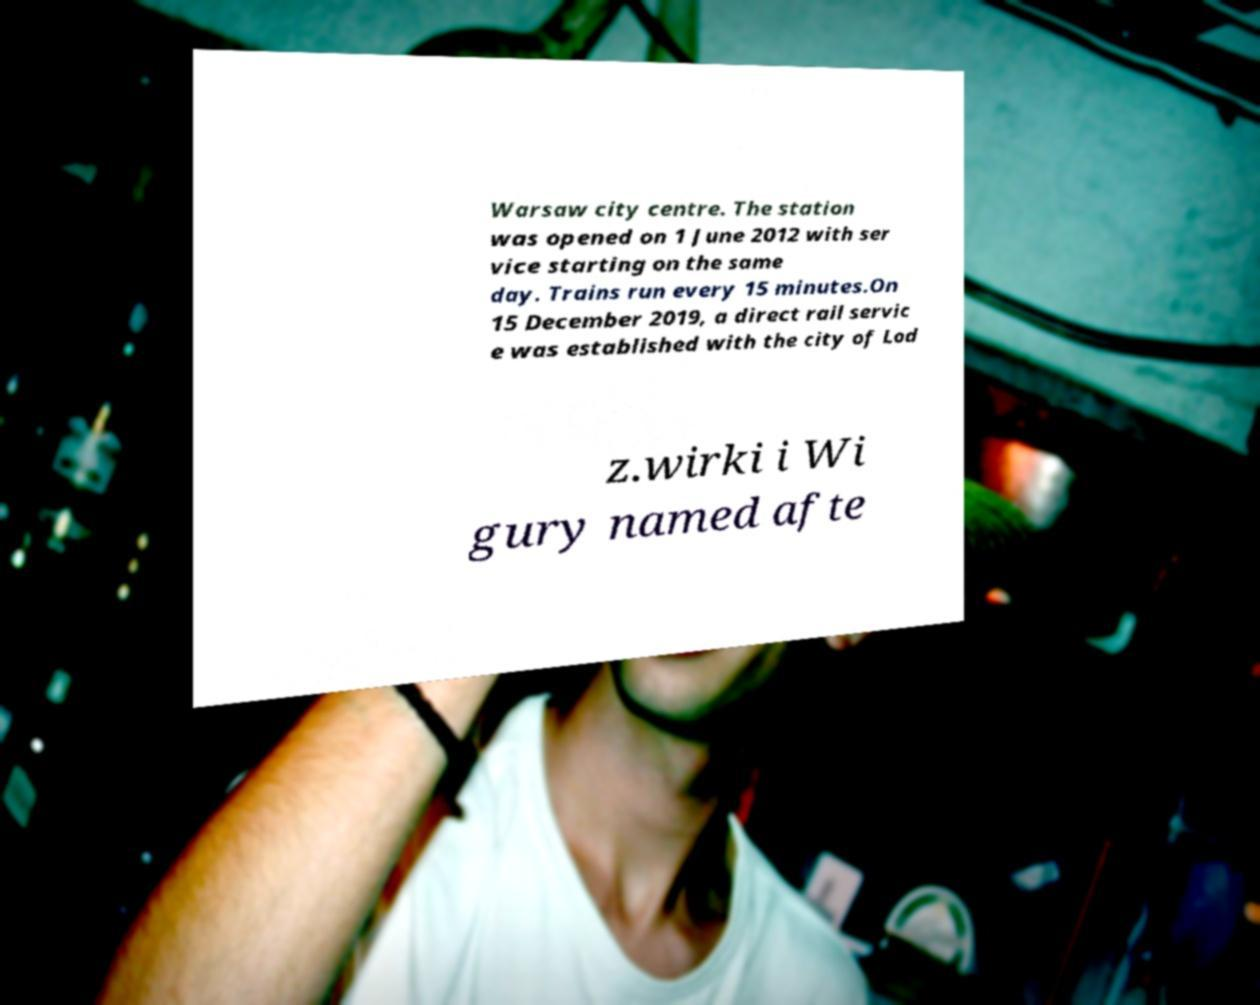Could you assist in decoding the text presented in this image and type it out clearly? Warsaw city centre. The station was opened on 1 June 2012 with ser vice starting on the same day. Trains run every 15 minutes.On 15 December 2019, a direct rail servic e was established with the city of Lod z.wirki i Wi gury named afte 